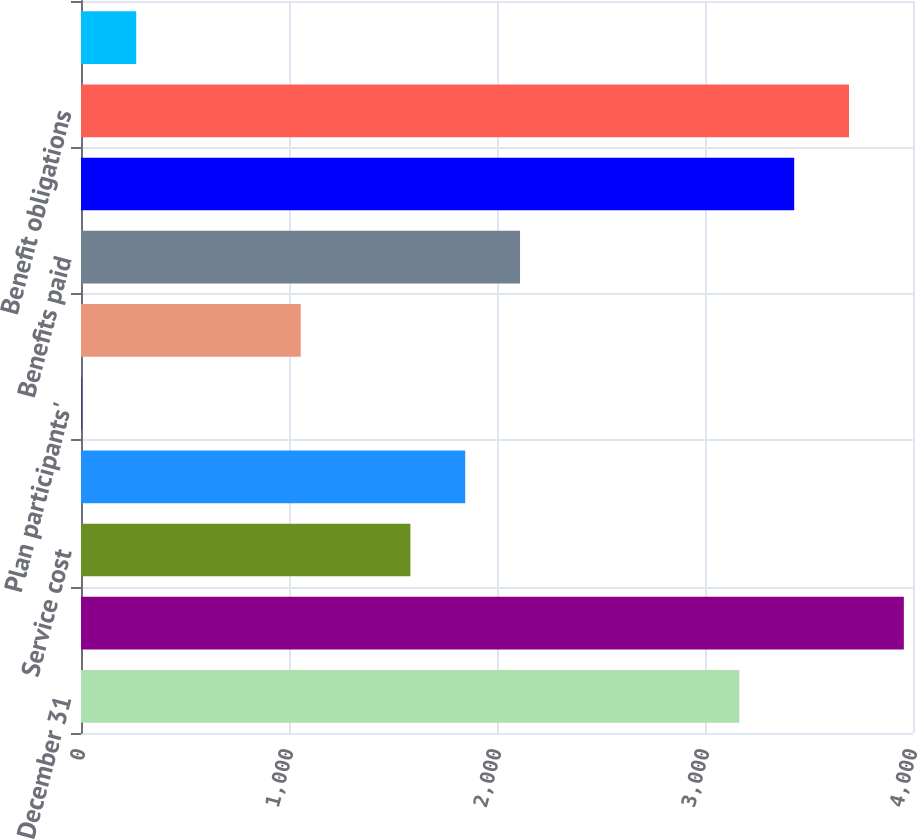Convert chart to OTSL. <chart><loc_0><loc_0><loc_500><loc_500><bar_chart><fcel>December 31<fcel>Benefit obligation at<fcel>Service cost<fcel>Interest cost<fcel>Plan participants'<fcel>Actuarial losses (gains)<fcel>Benefits paid<fcel>Benefit obligation at end of<fcel>Benefit obligations<fcel>Funded status of plans<nl><fcel>3165.2<fcel>3956<fcel>1583.6<fcel>1847.2<fcel>2<fcel>1056.4<fcel>2110.8<fcel>3428.8<fcel>3692.4<fcel>265.6<nl></chart> 